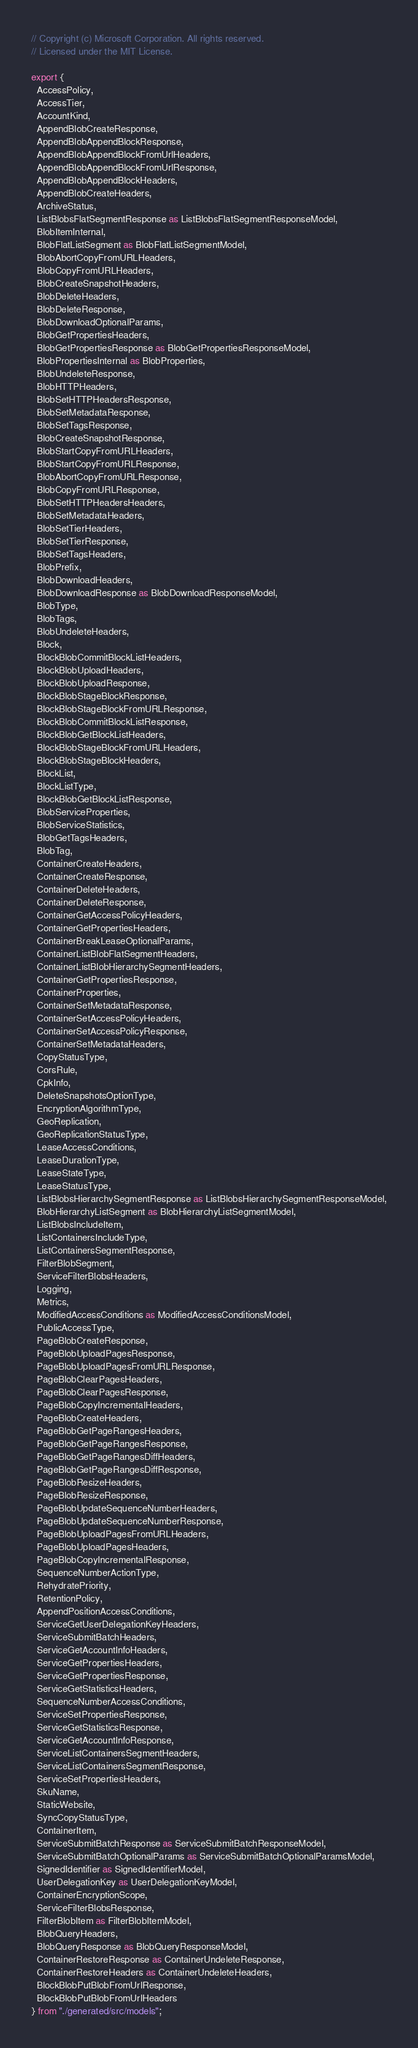<code> <loc_0><loc_0><loc_500><loc_500><_TypeScript_>// Copyright (c) Microsoft Corporation. All rights reserved.
// Licensed under the MIT License.

export {
  AccessPolicy,
  AccessTier,
  AccountKind,
  AppendBlobCreateResponse,
  AppendBlobAppendBlockResponse,
  AppendBlobAppendBlockFromUrlHeaders,
  AppendBlobAppendBlockFromUrlResponse,
  AppendBlobAppendBlockHeaders,
  AppendBlobCreateHeaders,
  ArchiveStatus,
  ListBlobsFlatSegmentResponse as ListBlobsFlatSegmentResponseModel,
  BlobItemInternal,
  BlobFlatListSegment as BlobFlatListSegmentModel,
  BlobAbortCopyFromURLHeaders,
  BlobCopyFromURLHeaders,
  BlobCreateSnapshotHeaders,
  BlobDeleteHeaders,
  BlobDeleteResponse,
  BlobDownloadOptionalParams,
  BlobGetPropertiesHeaders,
  BlobGetPropertiesResponse as BlobGetPropertiesResponseModel,
  BlobPropertiesInternal as BlobProperties,
  BlobUndeleteResponse,
  BlobHTTPHeaders,
  BlobSetHTTPHeadersResponse,
  BlobSetMetadataResponse,
  BlobSetTagsResponse,
  BlobCreateSnapshotResponse,
  BlobStartCopyFromURLHeaders,
  BlobStartCopyFromURLResponse,
  BlobAbortCopyFromURLResponse,
  BlobCopyFromURLResponse,
  BlobSetHTTPHeadersHeaders,
  BlobSetMetadataHeaders,
  BlobSetTierHeaders,
  BlobSetTierResponse,
  BlobSetTagsHeaders,
  BlobPrefix,
  BlobDownloadHeaders,
  BlobDownloadResponse as BlobDownloadResponseModel,
  BlobType,
  BlobTags,
  BlobUndeleteHeaders,
  Block,
  BlockBlobCommitBlockListHeaders,
  BlockBlobUploadHeaders,
  BlockBlobUploadResponse,
  BlockBlobStageBlockResponse,
  BlockBlobStageBlockFromURLResponse,
  BlockBlobCommitBlockListResponse,
  BlockBlobGetBlockListHeaders,
  BlockBlobStageBlockFromURLHeaders,
  BlockBlobStageBlockHeaders,
  BlockList,
  BlockListType,
  BlockBlobGetBlockListResponse,
  BlobServiceProperties,
  BlobServiceStatistics,
  BlobGetTagsHeaders,
  BlobTag,
  ContainerCreateHeaders,
  ContainerCreateResponse,
  ContainerDeleteHeaders,
  ContainerDeleteResponse,
  ContainerGetAccessPolicyHeaders,
  ContainerGetPropertiesHeaders,
  ContainerBreakLeaseOptionalParams,
  ContainerListBlobFlatSegmentHeaders,
  ContainerListBlobHierarchySegmentHeaders,
  ContainerGetPropertiesResponse,
  ContainerProperties,
  ContainerSetMetadataResponse,
  ContainerSetAccessPolicyHeaders,
  ContainerSetAccessPolicyResponse,
  ContainerSetMetadataHeaders,
  CopyStatusType,
  CorsRule,
  CpkInfo,
  DeleteSnapshotsOptionType,
  EncryptionAlgorithmType,
  GeoReplication,
  GeoReplicationStatusType,
  LeaseAccessConditions,
  LeaseDurationType,
  LeaseStateType,
  LeaseStatusType,
  ListBlobsHierarchySegmentResponse as ListBlobsHierarchySegmentResponseModel,
  BlobHierarchyListSegment as BlobHierarchyListSegmentModel,
  ListBlobsIncludeItem,
  ListContainersIncludeType,
  ListContainersSegmentResponse,
  FilterBlobSegment,
  ServiceFilterBlobsHeaders,
  Logging,
  Metrics,
  ModifiedAccessConditions as ModifiedAccessConditionsModel,
  PublicAccessType,
  PageBlobCreateResponse,
  PageBlobUploadPagesResponse,
  PageBlobUploadPagesFromURLResponse,
  PageBlobClearPagesHeaders,
  PageBlobClearPagesResponse,
  PageBlobCopyIncrementalHeaders,
  PageBlobCreateHeaders,
  PageBlobGetPageRangesHeaders,
  PageBlobGetPageRangesResponse,
  PageBlobGetPageRangesDiffHeaders,
  PageBlobGetPageRangesDiffResponse,
  PageBlobResizeHeaders,
  PageBlobResizeResponse,
  PageBlobUpdateSequenceNumberHeaders,
  PageBlobUpdateSequenceNumberResponse,
  PageBlobUploadPagesFromURLHeaders,
  PageBlobUploadPagesHeaders,
  PageBlobCopyIncrementalResponse,
  SequenceNumberActionType,
  RehydratePriority,
  RetentionPolicy,
  AppendPositionAccessConditions,
  ServiceGetUserDelegationKeyHeaders,
  ServiceSubmitBatchHeaders,
  ServiceGetAccountInfoHeaders,
  ServiceGetPropertiesHeaders,
  ServiceGetPropertiesResponse,
  ServiceGetStatisticsHeaders,
  SequenceNumberAccessConditions,
  ServiceSetPropertiesResponse,
  ServiceGetStatisticsResponse,
  ServiceGetAccountInfoResponse,
  ServiceListContainersSegmentHeaders,
  ServiceListContainersSegmentResponse,
  ServiceSetPropertiesHeaders,
  SkuName,
  StaticWebsite,
  SyncCopyStatusType,
  ContainerItem,
  ServiceSubmitBatchResponse as ServiceSubmitBatchResponseModel,
  ServiceSubmitBatchOptionalParams as ServiceSubmitBatchOptionalParamsModel,
  SignedIdentifier as SignedIdentifierModel,
  UserDelegationKey as UserDelegationKeyModel,
  ContainerEncryptionScope,
  ServiceFilterBlobsResponse,
  FilterBlobItem as FilterBlobItemModel,
  BlobQueryHeaders,
  BlobQueryResponse as BlobQueryResponseModel,
  ContainerRestoreResponse as ContainerUndeleteResponse,
  ContainerRestoreHeaders as ContainerUndeleteHeaders,
  BlockBlobPutBlobFromUrlResponse,
  BlockBlobPutBlobFromUrlHeaders
} from "./generated/src/models";
</code> 